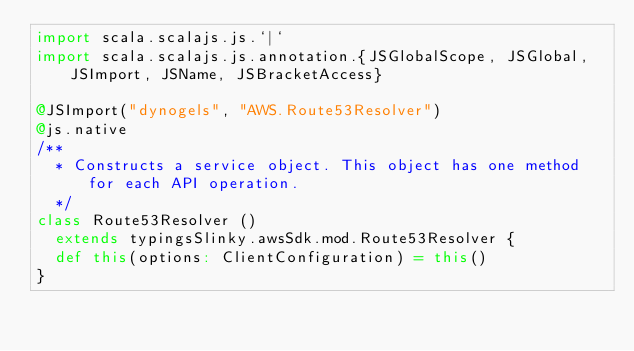<code> <loc_0><loc_0><loc_500><loc_500><_Scala_>import scala.scalajs.js.`|`
import scala.scalajs.js.annotation.{JSGlobalScope, JSGlobal, JSImport, JSName, JSBracketAccess}

@JSImport("dynogels", "AWS.Route53Resolver")
@js.native
/**
  * Constructs a service object. This object has one method for each API operation.
  */
class Route53Resolver ()
  extends typingsSlinky.awsSdk.mod.Route53Resolver {
  def this(options: ClientConfiguration) = this()
}
</code> 